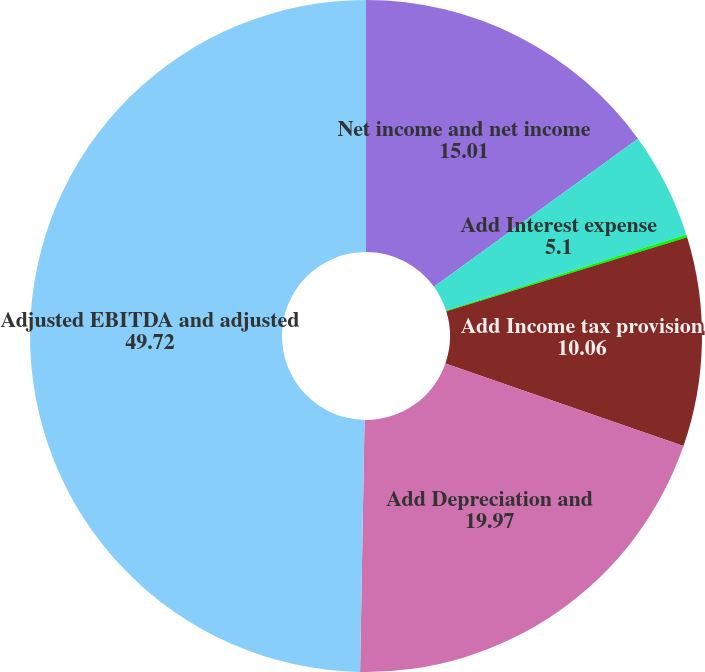Convert chart to OTSL. <chart><loc_0><loc_0><loc_500><loc_500><pie_chart><fcel>Net income and net income<fcel>Add Interest expense<fcel>Less Other non-operating<fcel>Add Income tax provision<fcel>Add Depreciation and<fcel>Adjusted EBITDA and adjusted<nl><fcel>15.01%<fcel>5.1%<fcel>0.14%<fcel>10.06%<fcel>19.97%<fcel>49.72%<nl></chart> 